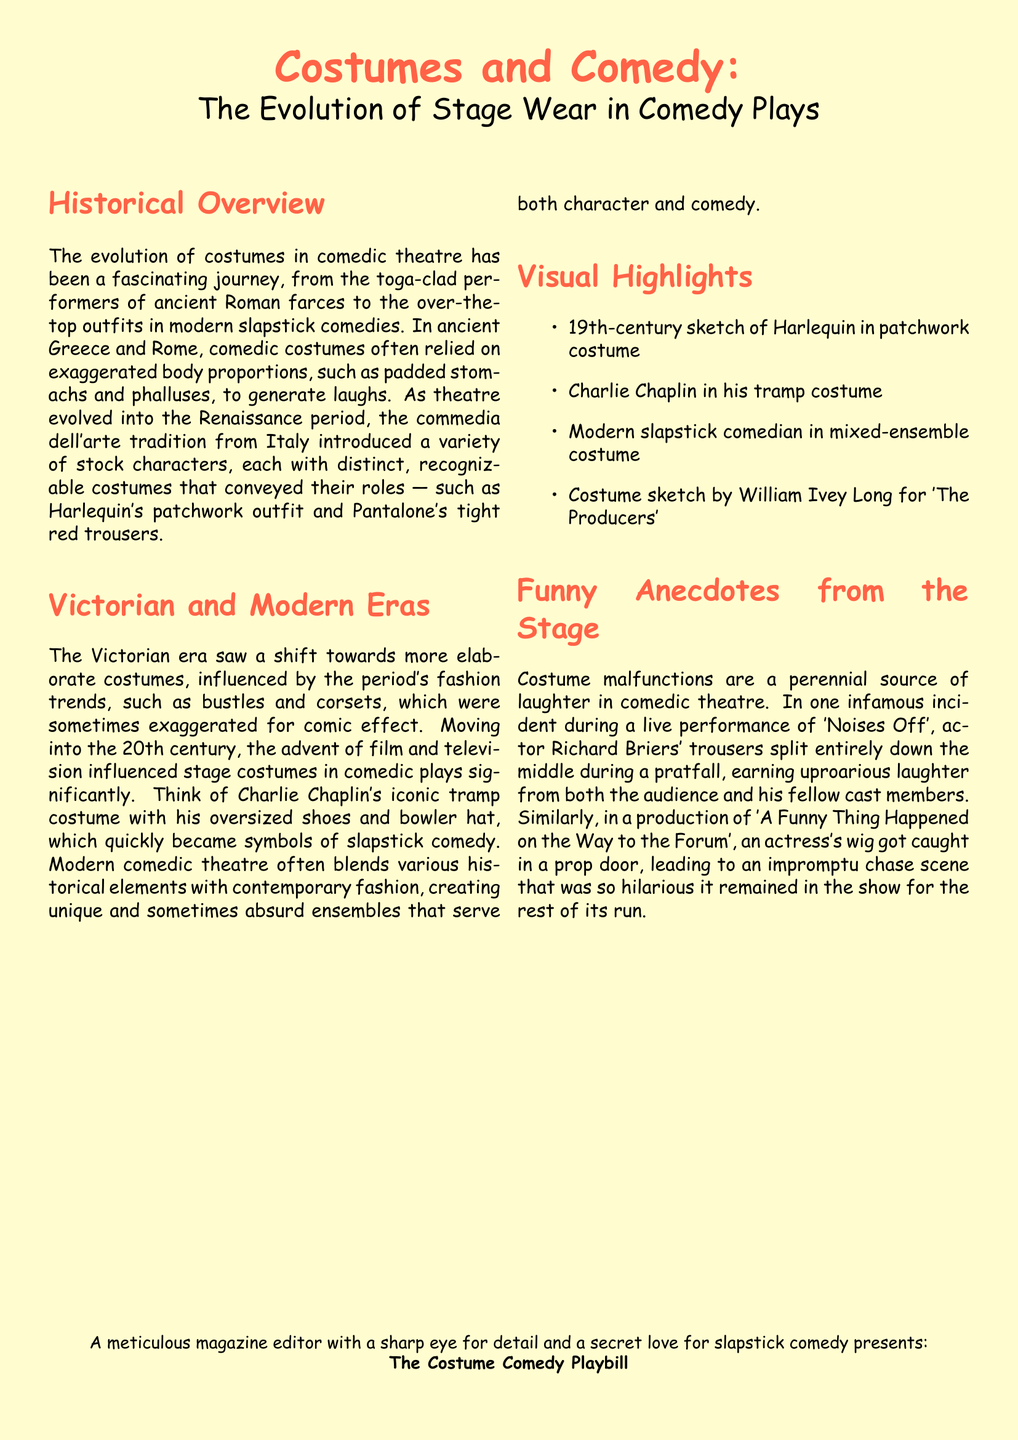what was a common costume feature in ancient comedic theatre? Ancient comedic theatre often relied on exaggerated body proportions, such as padded stomachs and phalluses, to generate laughs.
Answer: padded stomachs and phalluses who is known for the iconic tramp costume? The document mentions Charlie Chaplin and his signature style associated with slapstick comedy.
Answer: Charlie Chaplin which famous production included a costume malfunction involving Richard Briers? The incident involving Richard Briers' trousers split occurred during a live performance of a specific comedic play.
Answer: Noises Off what is a visual highlight featured in the document? The document provides several notable visual highlights related to comedic costumes.
Answer: Charlie Chaplin in his tramp costume what comedic character's costume is recognized for its patchwork design? The document references a specific character known for a distinct costume style that is easily recognizable among comedic characters.
Answer: Harlequin which era saw a shift towards elaborate costumes influenced by fashion trends? The document discusses a specific period reflecting changes in comedic theatre and costume design.
Answer: Victorian era what humorous event resulted from a wig getting caught in a prop door? The document describes a specific scenario that caused an unexpected comedic moment during a stage production.
Answer: impromptu chase scene who created the costume sketch for 'The Producers'? The document mentions a person recognized for their contribution to a costume design in a well-known comedic production.
Answer: William Ivey Long 